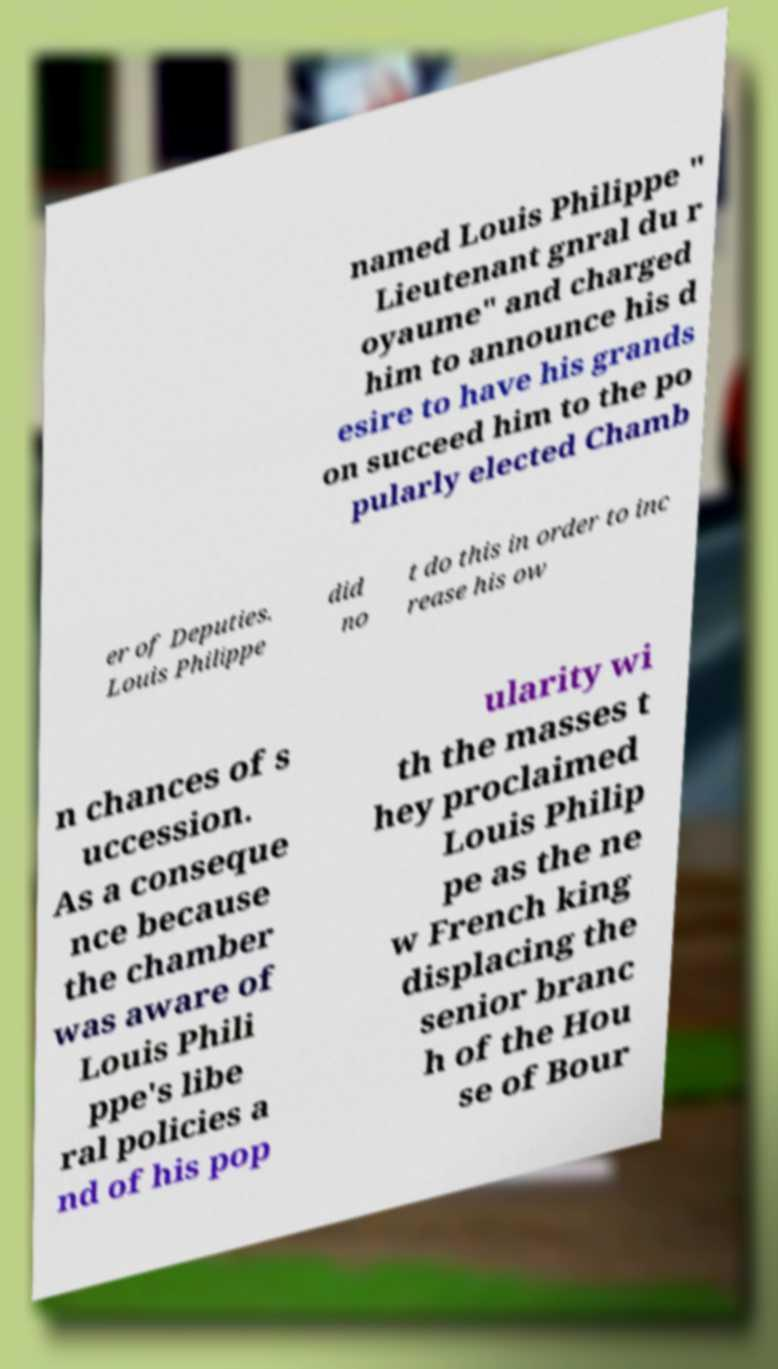Can you read and provide the text displayed in the image?This photo seems to have some interesting text. Can you extract and type it out for me? named Louis Philippe " Lieutenant gnral du r oyaume" and charged him to announce his d esire to have his grands on succeed him to the po pularly elected Chamb er of Deputies. Louis Philippe did no t do this in order to inc rease his ow n chances of s uccession. As a conseque nce because the chamber was aware of Louis Phili ppe's libe ral policies a nd of his pop ularity wi th the masses t hey proclaimed Louis Philip pe as the ne w French king displacing the senior branc h of the Hou se of Bour 